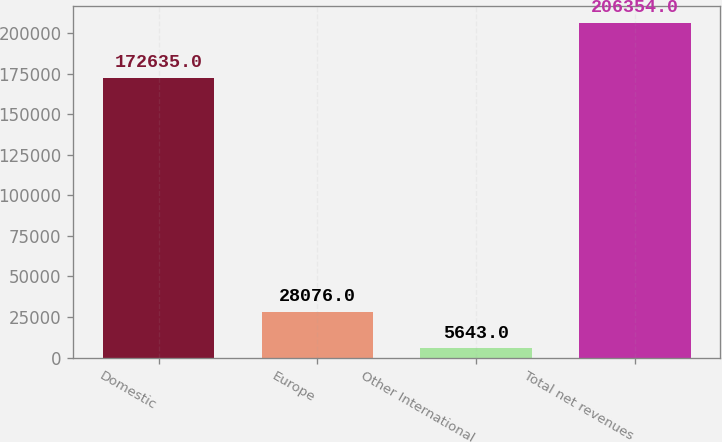Convert chart to OTSL. <chart><loc_0><loc_0><loc_500><loc_500><bar_chart><fcel>Domestic<fcel>Europe<fcel>Other International<fcel>Total net revenues<nl><fcel>172635<fcel>28076<fcel>5643<fcel>206354<nl></chart> 